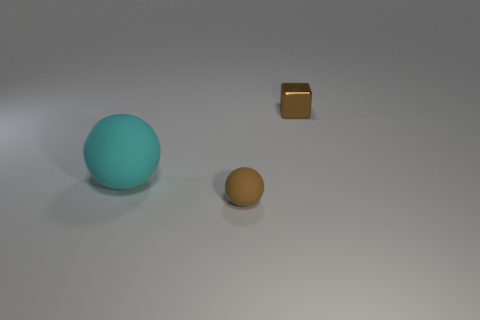There is a ball that is left of the tiny brown object to the left of the tiny brown cube; how big is it?
Your response must be concise. Large. Is the number of brown rubber objects less than the number of big yellow things?
Give a very brief answer. No. There is a object that is both to the left of the small metal object and right of the large cyan rubber object; what size is it?
Offer a very short reply. Small. There is a tiny shiny block on the right side of the brown ball; is its color the same as the small rubber object?
Your answer should be compact. Yes. Are there fewer small shiny cubes that are in front of the large rubber thing than tiny brown balls?
Your answer should be very brief. Yes. There is another thing that is made of the same material as the big cyan thing; what shape is it?
Offer a terse response. Sphere. Are the large sphere and the tiny cube made of the same material?
Ensure brevity in your answer.  No. Are there fewer large matte things in front of the tiny matte object than cubes to the right of the big rubber thing?
Your answer should be very brief. Yes. What number of large rubber balls are in front of the brown object behind the matte sphere that is to the right of the cyan matte object?
Make the answer very short. 1. Do the metal cube and the tiny rubber ball have the same color?
Offer a very short reply. Yes. 